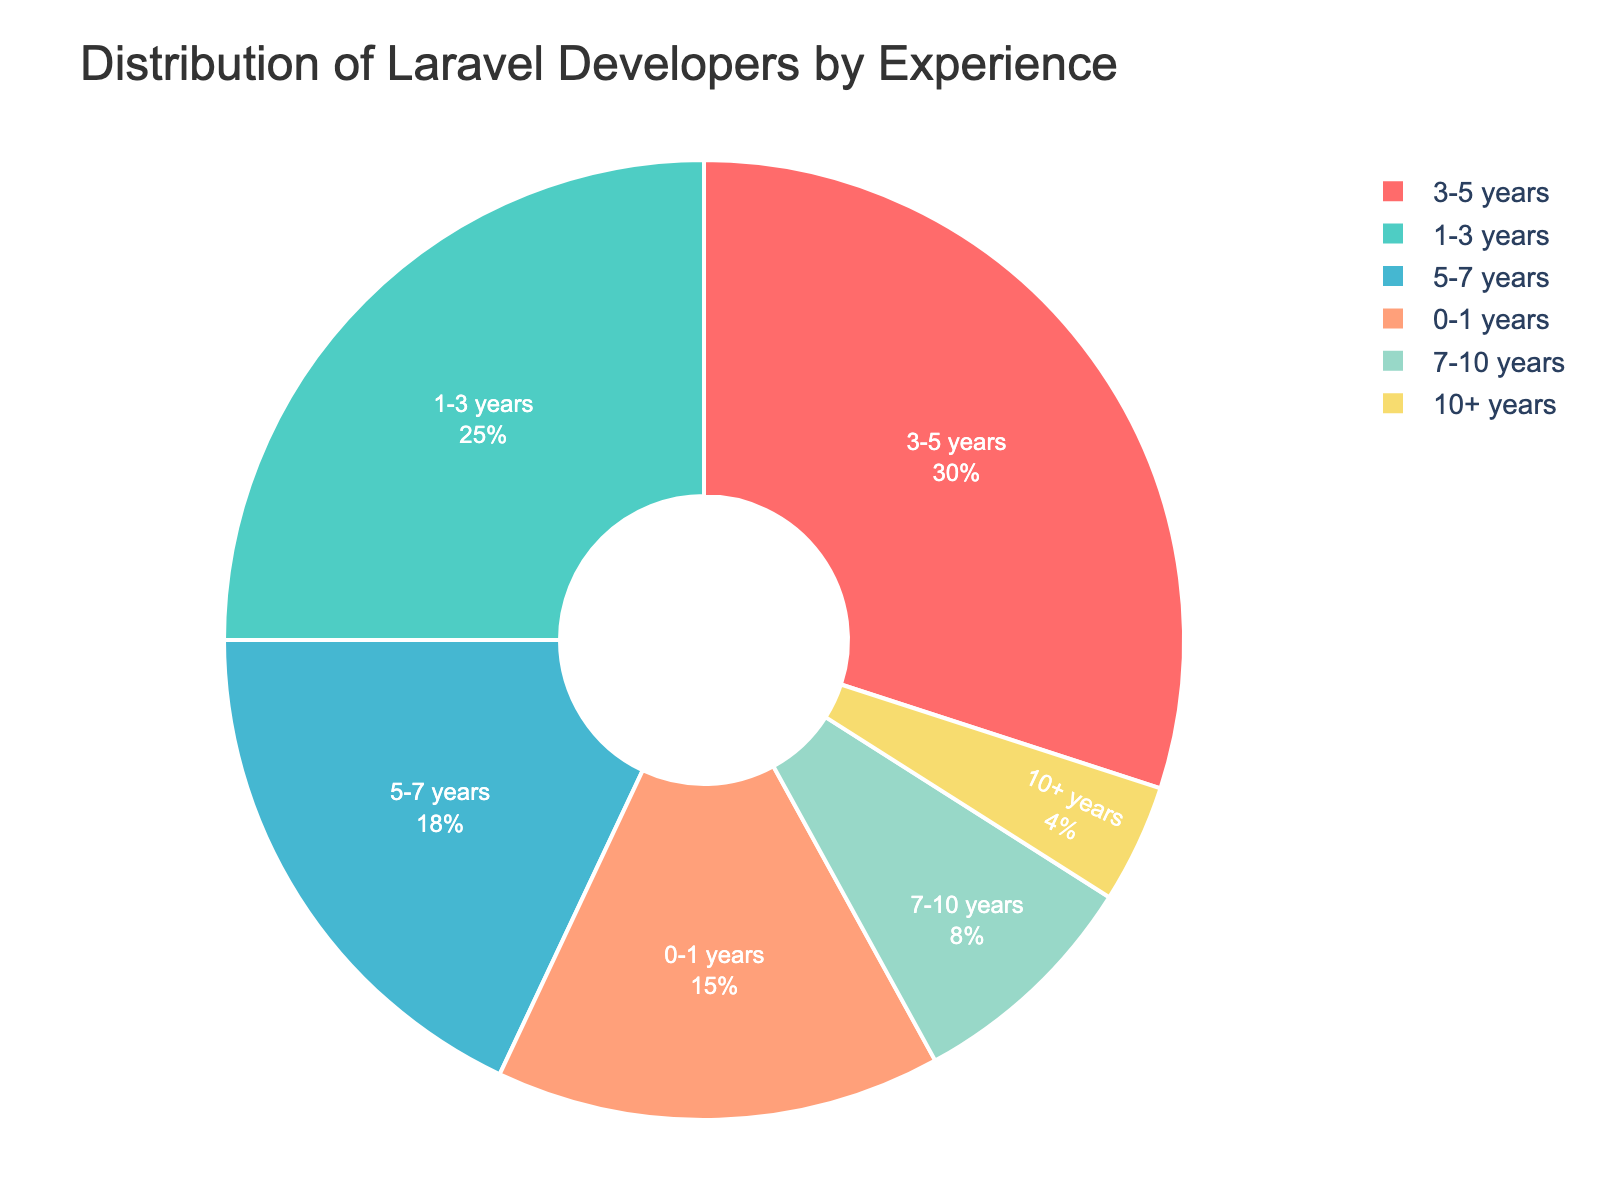What percentage of Laravel developers have between 3-5 years of experience? The figure shows the percentage of developers with different years of experience. Referring to the slice labeled "3-5 years", the percentage indicated is 30%.
Answer: 30% How many percentage points more developers have 3-5 years of experience compared to 7-10 years? First identify the percentages: 3-5 years has 30% and 7-10 years has 8%. Compute the difference: 30% - 8% = 22 percentage points.
Answer: 22 Do more developers have 1-3 years or 5-7 years of experience? Refer to the slices labeled "1-3 years" and "5-7 years". Compare the percentages: 1-3 years is 25% and 5-7 years is 18%. Hence, more developers have 1-3 years of experience.
Answer: 1-3 years Are there more developers with 0-1 years of experience or with 10+ years of experience? Compare the percentages of the slices "0-1 years" (15%) and "10+ years" (4%). 15% is greater than 4%.
Answer: 0-1 years What is the total percentage of developers who have between 1 and 5 years of experience? Compute the sum of the slices for "1-3 years" and "3-5 years": 25% + 30% = 55%.
Answer: 55% Which slice has the smallest percentage, and what is that percentage? Identify the slice with the smallest percentage from the figure. The "10+ years" slice is the smallest with 4%.
Answer: 10+ years, 4% What percentage of developers have at least 5 years of experience? Sum the percentages for the slices "5-7 years" (18%), "7-10 years" (8%), and "10+ years" (4%): 18% + 8% + 4% = 30%.
Answer: 30% What are the colors used in the pie chart, and which color represents the developers with 0-1 years of experience? The chart uses six colors: red, turquoise, blue, salmon, light green, and yellow. The slice labeled "0-1 years" is red.
Answer: Red How many percentage points more developers have 5-7 years of experience compared to 0-1 years? Identify the percentages for "5-7 years" (18%) and "0-1 years" (15%). Compute the difference: 18% - 15% = 3 percentage points.
Answer: 3 